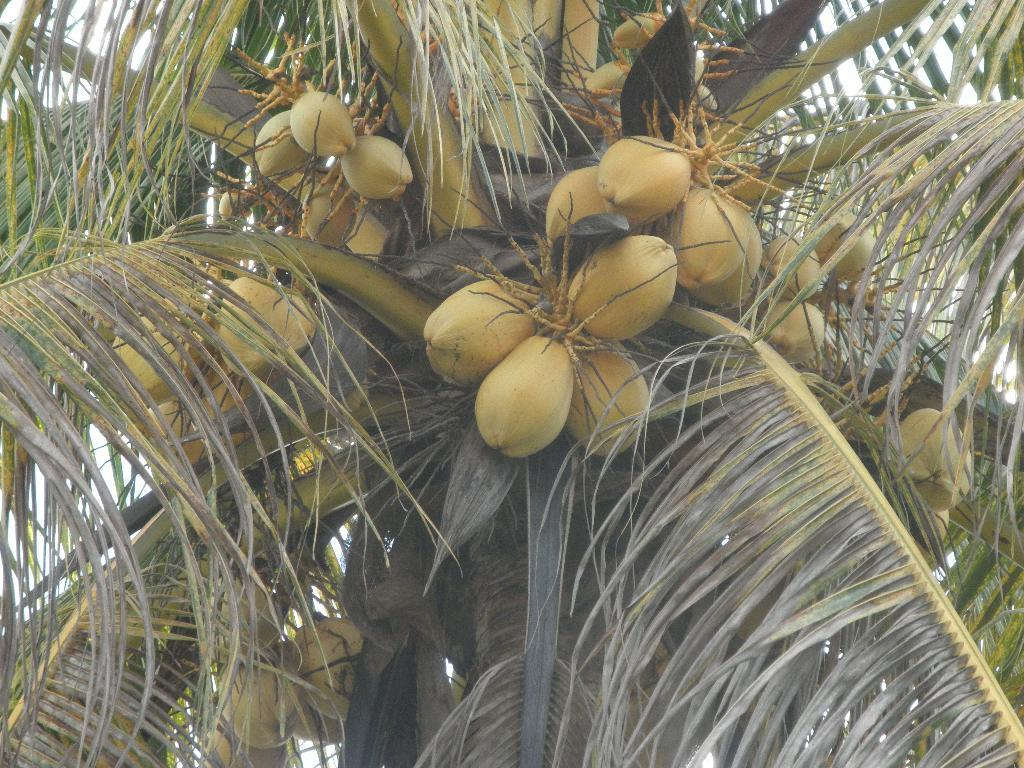What type of tree is in the picture? There is a coconut tree in the picture. Can you describe the coconuts in the picture? Yes, there are coconuts visible in the picture. What type of pin is holding the feeling in the image? There is no pin or feeling present in the image; it only features a coconut tree and coconuts. 